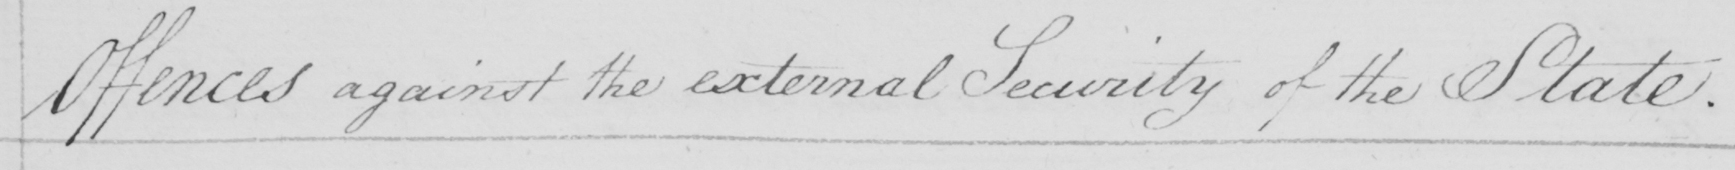What does this handwritten line say? Offences against the external Security of the State . 